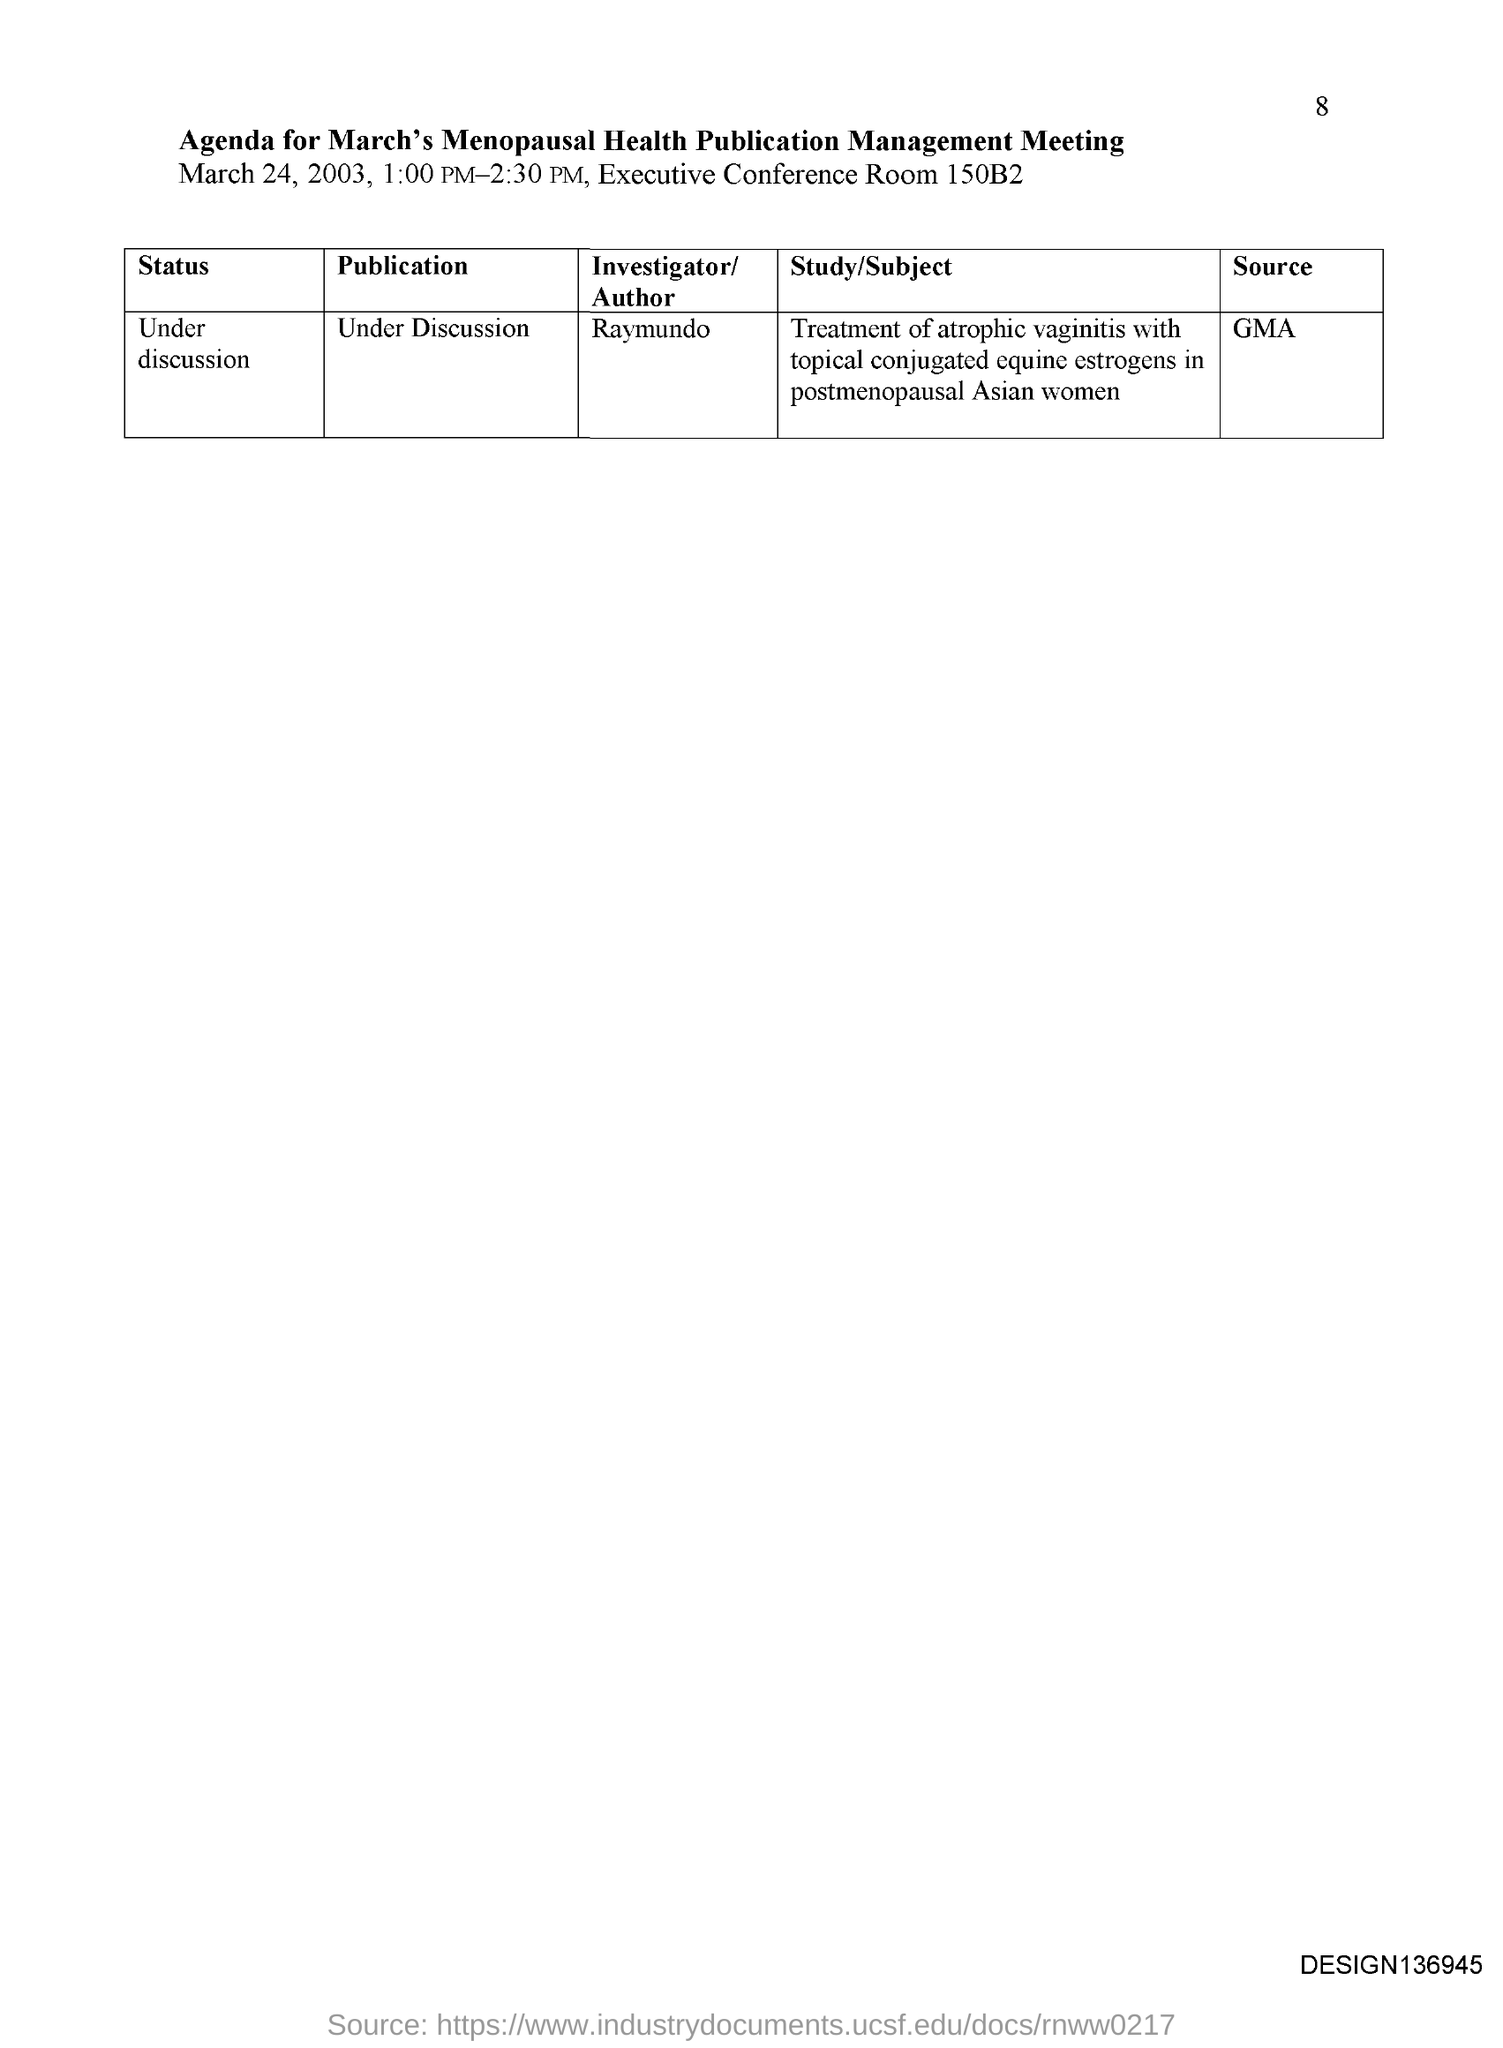Outline some significant characteristics in this image. The meeting is held in the Executive Conference Room located in 150B2. The meeting is held from 1:00 PM to 2:30 PM. What is the source? It is GMA.. The meeting will be held on March 24, 2003. 